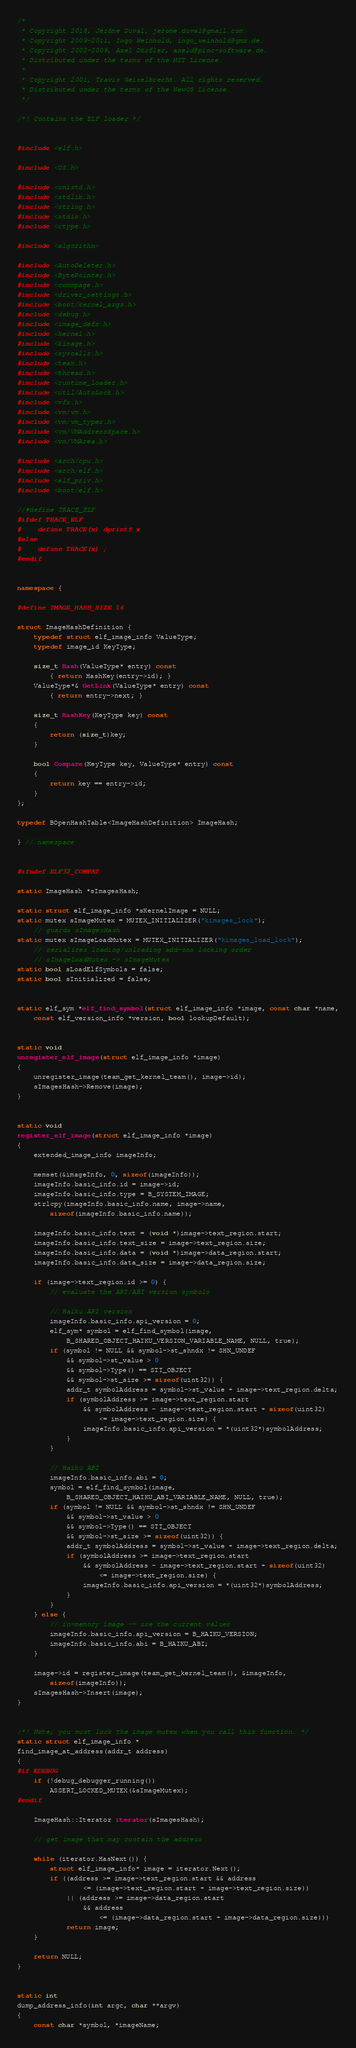<code> <loc_0><loc_0><loc_500><loc_500><_C++_>/*
 * Copyright 2018, Jérôme Duval, jerome.duval@gmail.com.
 * Copyright 2009-2011, Ingo Weinhold, ingo_weinhold@gmx.de.
 * Copyright 2002-2009, Axel Dörfler, axeld@pinc-software.de.
 * Distributed under the terms of the MIT License.
 *
 * Copyright 2001, Travis Geiselbrecht. All rights reserved.
 * Distributed under the terms of the NewOS License.
 */

/*!	Contains the ELF loader */


#include <elf.h>

#include <OS.h>

#include <unistd.h>
#include <stdlib.h>
#include <string.h>
#include <stdio.h>
#include <ctype.h>

#include <algorithm>

#include <AutoDeleter.h>
#include <BytePointer.h>
#include <commpage.h>
#include <driver_settings.h>
#include <boot/kernel_args.h>
#include <debug.h>
#include <image_defs.h>
#include <kernel.h>
#include <kimage.h>
#include <syscalls.h>
#include <team.h>
#include <thread.h>
#include <runtime_loader.h>
#include <util/AutoLock.h>
#include <vfs.h>
#include <vm/vm.h>
#include <vm/vm_types.h>
#include <vm/VMAddressSpace.h>
#include <vm/VMArea.h>

#include <arch/cpu.h>
#include <arch/elf.h>
#include <elf_priv.h>
#include <boot/elf.h>

//#define TRACE_ELF
#ifdef TRACE_ELF
#	define TRACE(x) dprintf x
#else
#	define TRACE(x) ;
#endif


namespace {

#define IMAGE_HASH_SIZE 16

struct ImageHashDefinition {
	typedef struct elf_image_info ValueType;
	typedef image_id KeyType;

	size_t Hash(ValueType* entry) const
		{ return HashKey(entry->id); }
	ValueType*& GetLink(ValueType* entry) const
		{ return entry->next; }

	size_t HashKey(KeyType key) const
	{
		return (size_t)key;
	}

	bool Compare(KeyType key, ValueType* entry) const
	{
		return key == entry->id;
	}
};

typedef BOpenHashTable<ImageHashDefinition> ImageHash;

} // namespace


#ifndef ELF32_COMPAT

static ImageHash *sImagesHash;

static struct elf_image_info *sKernelImage = NULL;
static mutex sImageMutex = MUTEX_INITIALIZER("kimages_lock");
	// guards sImagesHash
static mutex sImageLoadMutex = MUTEX_INITIALIZER("kimages_load_lock");
	// serializes loading/unloading add-ons locking order
	// sImageLoadMutex -> sImageMutex
static bool sLoadElfSymbols = false;
static bool sInitialized = false;


static elf_sym *elf_find_symbol(struct elf_image_info *image, const char *name,
	const elf_version_info *version, bool lookupDefault);


static void
unregister_elf_image(struct elf_image_info *image)
{
	unregister_image(team_get_kernel_team(), image->id);
	sImagesHash->Remove(image);
}


static void
register_elf_image(struct elf_image_info *image)
{
	extended_image_info imageInfo;

	memset(&imageInfo, 0, sizeof(imageInfo));
	imageInfo.basic_info.id = image->id;
	imageInfo.basic_info.type = B_SYSTEM_IMAGE;
	strlcpy(imageInfo.basic_info.name, image->name,
		sizeof(imageInfo.basic_info.name));

	imageInfo.basic_info.text = (void *)image->text_region.start;
	imageInfo.basic_info.text_size = image->text_region.size;
	imageInfo.basic_info.data = (void *)image->data_region.start;
	imageInfo.basic_info.data_size = image->data_region.size;

	if (image->text_region.id >= 0) {
		// evaluate the API/ABI version symbols

		// Haiku API version
		imageInfo.basic_info.api_version = 0;
		elf_sym* symbol = elf_find_symbol(image,
			B_SHARED_OBJECT_HAIKU_VERSION_VARIABLE_NAME, NULL, true);
		if (symbol != NULL && symbol->st_shndx != SHN_UNDEF
			&& symbol->st_value > 0
			&& symbol->Type() == STT_OBJECT
			&& symbol->st_size >= sizeof(uint32)) {
			addr_t symbolAddress = symbol->st_value + image->text_region.delta;
			if (symbolAddress >= image->text_region.start
				&& symbolAddress - image->text_region.start + sizeof(uint32)
					<= image->text_region.size) {
				imageInfo.basic_info.api_version = *(uint32*)symbolAddress;
			}
		}

		// Haiku ABI
		imageInfo.basic_info.abi = 0;
		symbol = elf_find_symbol(image,
			B_SHARED_OBJECT_HAIKU_ABI_VARIABLE_NAME, NULL, true);
		if (symbol != NULL && symbol->st_shndx != SHN_UNDEF
			&& symbol->st_value > 0
			&& symbol->Type() == STT_OBJECT
			&& symbol->st_size >= sizeof(uint32)) {
			addr_t symbolAddress = symbol->st_value + image->text_region.delta;
			if (symbolAddress >= image->text_region.start
				&& symbolAddress - image->text_region.start + sizeof(uint32)
					<= image->text_region.size) {
				imageInfo.basic_info.api_version = *(uint32*)symbolAddress;
			}
		}
	} else {
		// in-memory image -- use the current values
		imageInfo.basic_info.api_version = B_HAIKU_VERSION;
		imageInfo.basic_info.abi = B_HAIKU_ABI;
	}

	image->id = register_image(team_get_kernel_team(), &imageInfo,
		sizeof(imageInfo));
	sImagesHash->Insert(image);
}


/*!	Note, you must lock the image mutex when you call this function. */
static struct elf_image_info *
find_image_at_address(addr_t address)
{
#if KDEBUG
	if (!debug_debugger_running())
		ASSERT_LOCKED_MUTEX(&sImageMutex);
#endif

	ImageHash::Iterator iterator(sImagesHash);

	// get image that may contain the address

	while (iterator.HasNext()) {
		struct elf_image_info* image = iterator.Next();
		if ((address >= image->text_region.start && address
				<= (image->text_region.start + image->text_region.size))
			|| (address >= image->data_region.start
				&& address
					<= (image->data_region.start + image->data_region.size)))
			return image;
	}

	return NULL;
}


static int
dump_address_info(int argc, char **argv)
{
	const char *symbol, *imageName;</code> 